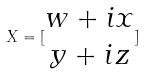Convert formula to latex. <formula><loc_0><loc_0><loc_500><loc_500>X = [ \begin{matrix} w + i x \\ y + i z \end{matrix} ]</formula> 